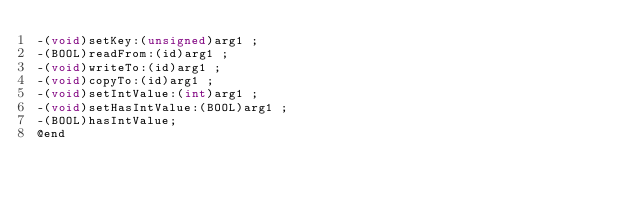<code> <loc_0><loc_0><loc_500><loc_500><_C_>-(void)setKey:(unsigned)arg1 ;
-(BOOL)readFrom:(id)arg1 ;
-(void)writeTo:(id)arg1 ;
-(void)copyTo:(id)arg1 ;
-(void)setIntValue:(int)arg1 ;
-(void)setHasIntValue:(BOOL)arg1 ;
-(BOOL)hasIntValue;
@end

</code> 